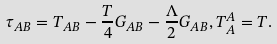<formula> <loc_0><loc_0><loc_500><loc_500>\tau _ { A B } = T _ { A B } - \frac { T } { 4 } G _ { A B } - \frac { \Lambda } { 2 } G _ { A B } , T _ { A } ^ { A } = T .</formula> 